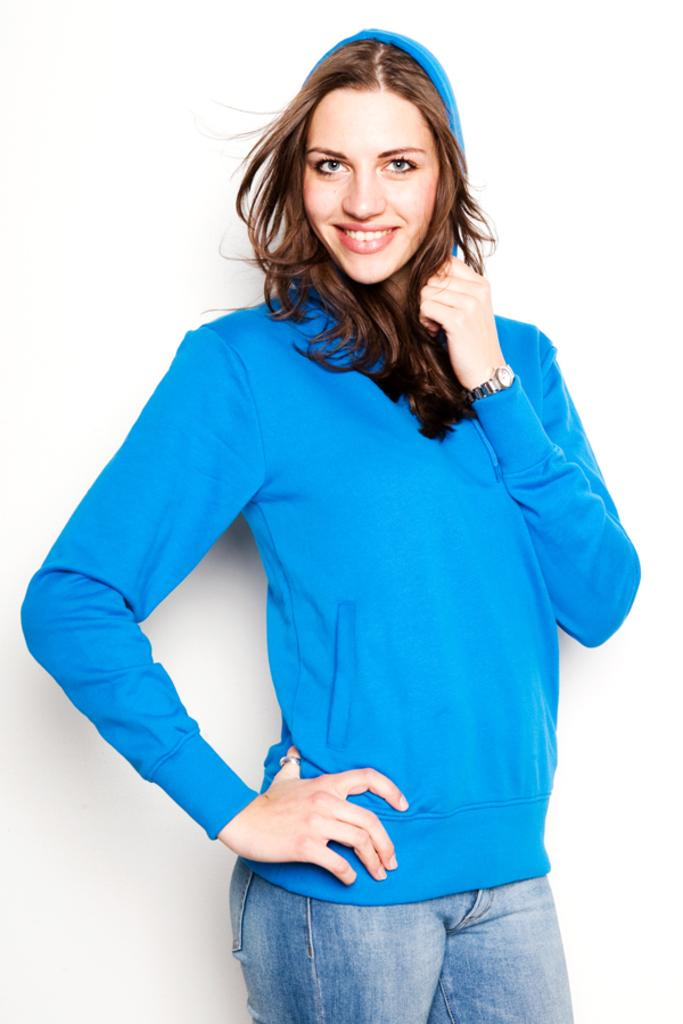Who is the main subject in the picture? There is a woman in the picture. What is the woman wearing? The woman is wearing a blue sweater. Are there any accessories visible on the woman? Yes, the woman is wearing a watch. What is the woman's facial expression? The woman is smiling. What is the woman's posture in the image? The woman is standing. What route is the woman planning to take with the committee in the image? There is no mention of a route or committee in the image; it only features a woman wearing a blue sweater, a watch, and smiling while standing. 